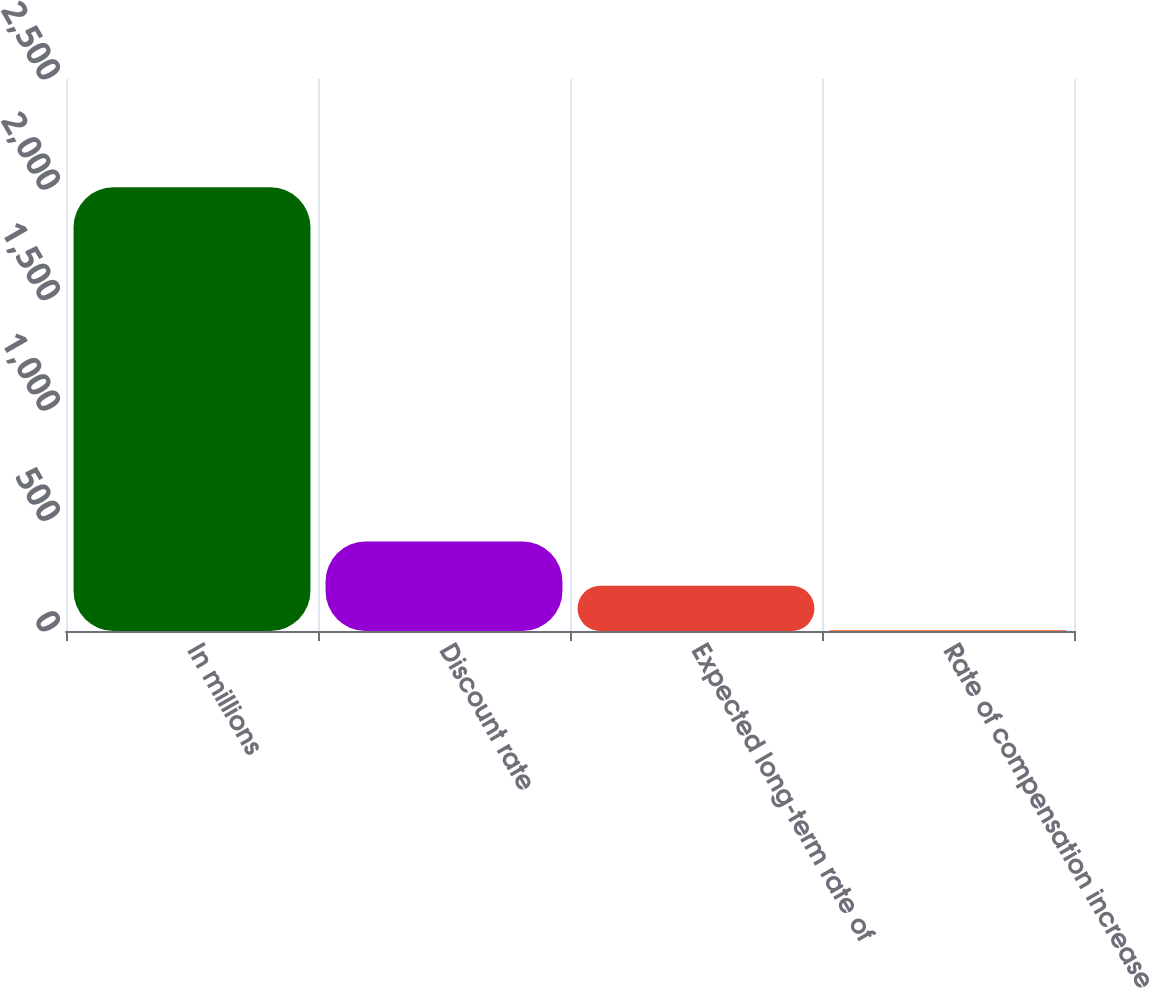Convert chart to OTSL. <chart><loc_0><loc_0><loc_500><loc_500><bar_chart><fcel>In millions<fcel>Discount rate<fcel>Expected long-term rate of<fcel>Rate of compensation increase<nl><fcel>2010<fcel>405.2<fcel>204.6<fcel>4<nl></chart> 